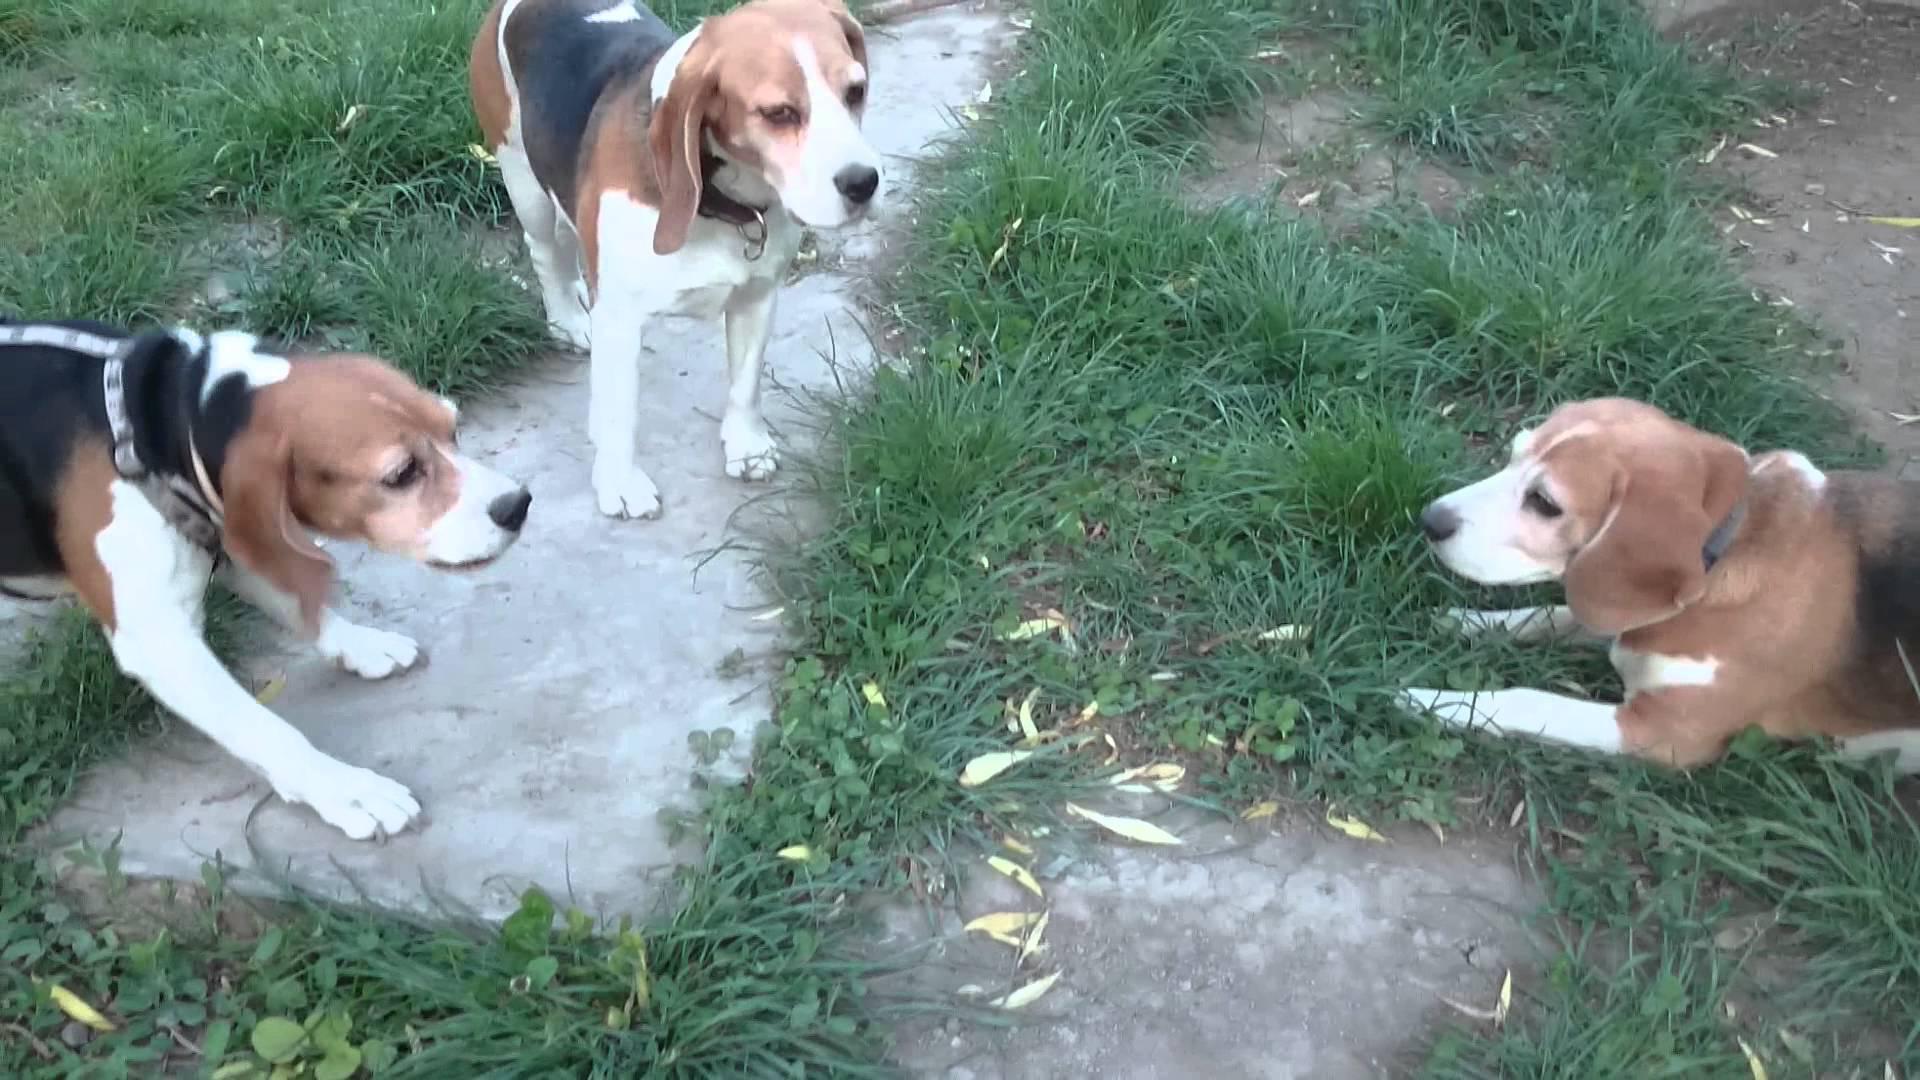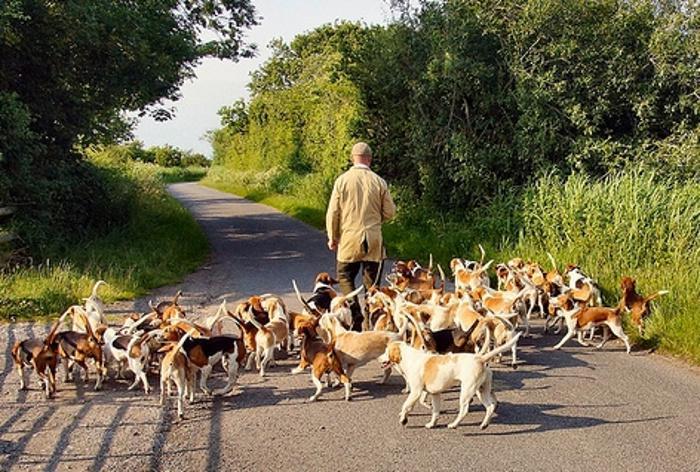The first image is the image on the left, the second image is the image on the right. For the images displayed, is the sentence "A man is with a group of dogs in a grassy area in the image on the left." factually correct? Answer yes or no. No. 